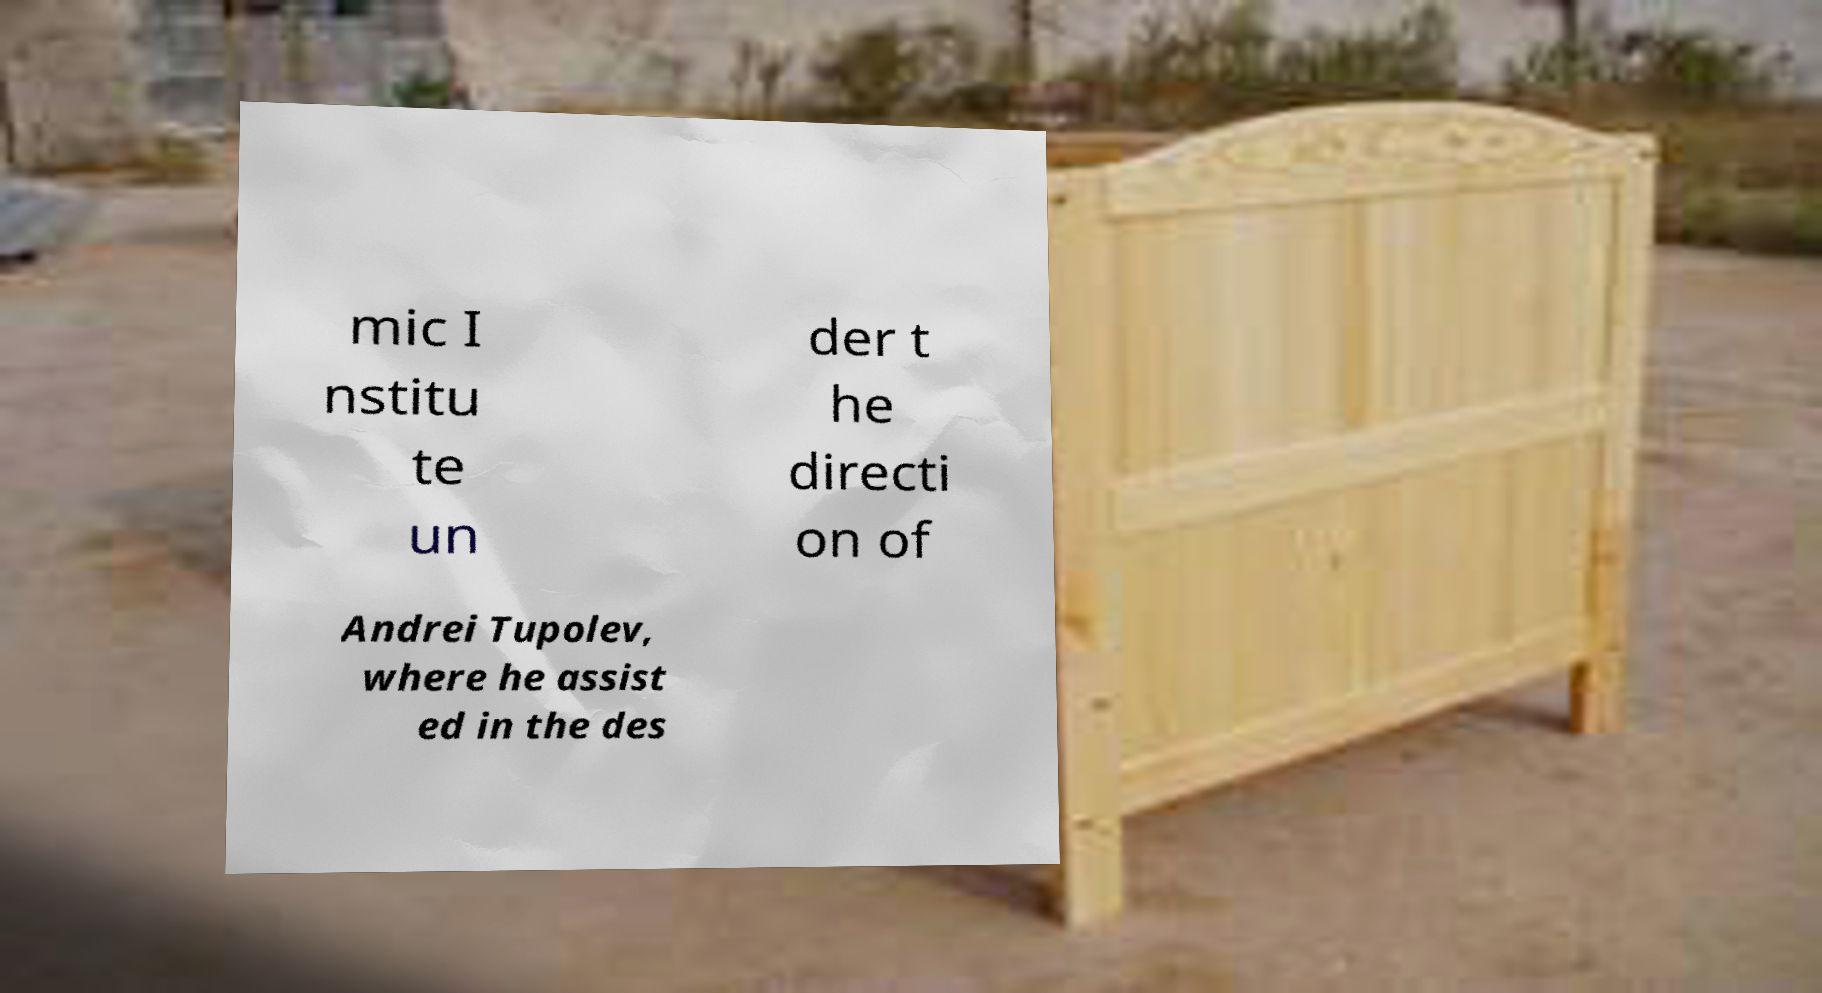Could you extract and type out the text from this image? mic I nstitu te un der t he directi on of Andrei Tupolev, where he assist ed in the des 